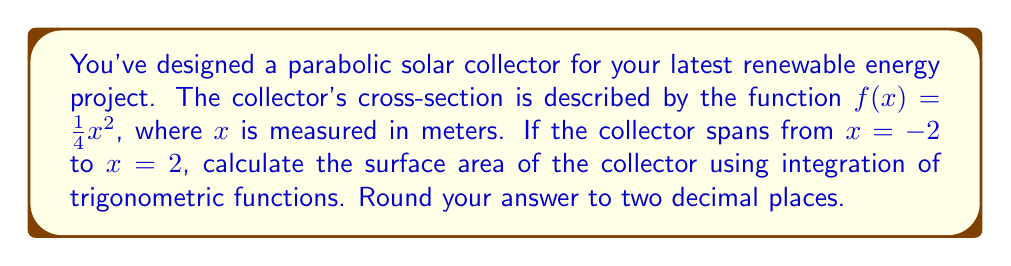Show me your answer to this math problem. To find the surface area of the parabolic solar collector, we need to use the formula for the surface area of a surface of revolution:

$$A = 2\pi \int_{a}^{b} f(x)\sqrt{1 + [f'(x)]^2} dx$$

Where $f(x)$ is the function describing the curve, and $[a, b]$ is the interval.

Given:
- $f(x) = \frac{1}{4}x^2$
- Interval: $[-2, 2]$

Steps:
1) First, find $f'(x)$:
   $f'(x) = \frac{1}{2}x$

2) Substitute into the surface area formula:
   $$A = 2\pi \int_{-2}^{2} \frac{1}{4}x^2 \sqrt{1 + (\frac{1}{2}x)^2} dx$$

3) Simplify the integrand:
   $$A = 2\pi \int_{-2}^{2} \frac{1}{4}x^2 \sqrt{1 + \frac{1}{4}x^2} dx$$

4) This integral is challenging to solve directly. Let's use trigonometric substitution:
   Let $x = 2\tan\theta$, then $dx = 2\sec^2\theta d\theta$

5) When $x = -2$, $\theta = -\frac{\pi}{4}$; when $x = 2$, $\theta = \frac{\pi}{4}$

6) Substituting:
   $$A = 2\pi \int_{-\frac{\pi}{4}}^{\frac{\pi}{4}} \frac{1}{4}(2\tan\theta)^2 \sqrt{1 + \frac{1}{4}(2\tan\theta)^2} (2\sec^2\theta) d\theta$$

7) Simplify:
   $$A = 2\pi \int_{-\frac{\pi}{4}}^{\frac{\pi}{4}} \tan^2\theta \sqrt{1 + \tan^2\theta} \sec^2\theta d\theta$$

8) Recall that $1 + \tan^2\theta = \sec^2\theta$:
   $$A = 2\pi \int_{-\frac{\pi}{4}}^{\frac{\pi}{4}} \tan^2\theta \sec^3\theta d\theta$$

9) This integral can be solved using trigonometric identities and u-substitution. The result is:
   $$A = 2\pi [\frac{1}{3}\tan^3\theta \sec\theta]_{-\frac{\pi}{4}}^{\frac{\pi}{4}}$$

10) Evaluate:
    $$A = 2\pi [\frac{1}{3}(1)^3(\sqrt{2}) - \frac{1}{3}(-1)^3(\sqrt{2})]$$
    $$A = 2\pi [\frac{2\sqrt{2}}{3}]$$
    $$A = \frac{4\pi\sqrt{2}}{3} \approx 5.92$$

Therefore, the surface area of the parabolic solar collector is approximately 5.92 square meters.
Answer: 5.92 square meters 